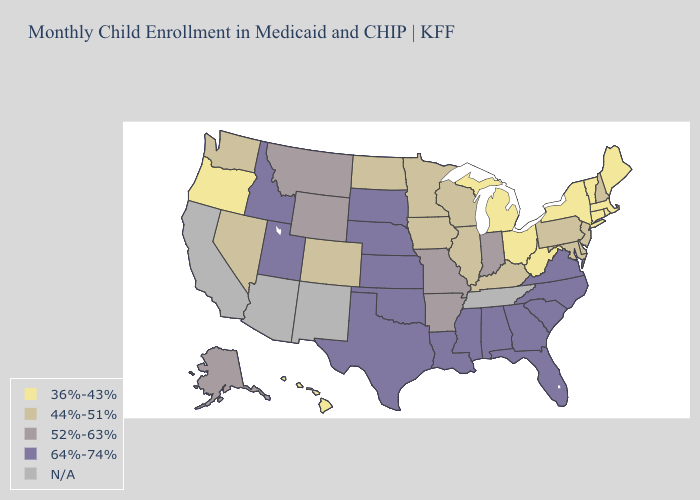What is the value of Utah?
Keep it brief. 64%-74%. What is the lowest value in states that border South Carolina?
Answer briefly. 64%-74%. Which states hav the highest value in the Northeast?
Write a very short answer. New Hampshire, New Jersey, Pennsylvania. What is the value of New York?
Concise answer only. 36%-43%. Name the states that have a value in the range N/A?
Keep it brief. Arizona, California, New Mexico, Tennessee. Which states hav the highest value in the Northeast?
Give a very brief answer. New Hampshire, New Jersey, Pennsylvania. What is the highest value in the MidWest ?
Answer briefly. 64%-74%. What is the highest value in states that border Mississippi?
Quick response, please. 64%-74%. What is the value of Oregon?
Keep it brief. 36%-43%. Does the first symbol in the legend represent the smallest category?
Answer briefly. Yes. Which states have the lowest value in the Northeast?
Give a very brief answer. Connecticut, Maine, Massachusetts, New York, Rhode Island, Vermont. Name the states that have a value in the range 64%-74%?
Answer briefly. Alabama, Florida, Georgia, Idaho, Kansas, Louisiana, Mississippi, Nebraska, North Carolina, Oklahoma, South Carolina, South Dakota, Texas, Utah, Virginia. What is the value of Maryland?
Concise answer only. 44%-51%. 